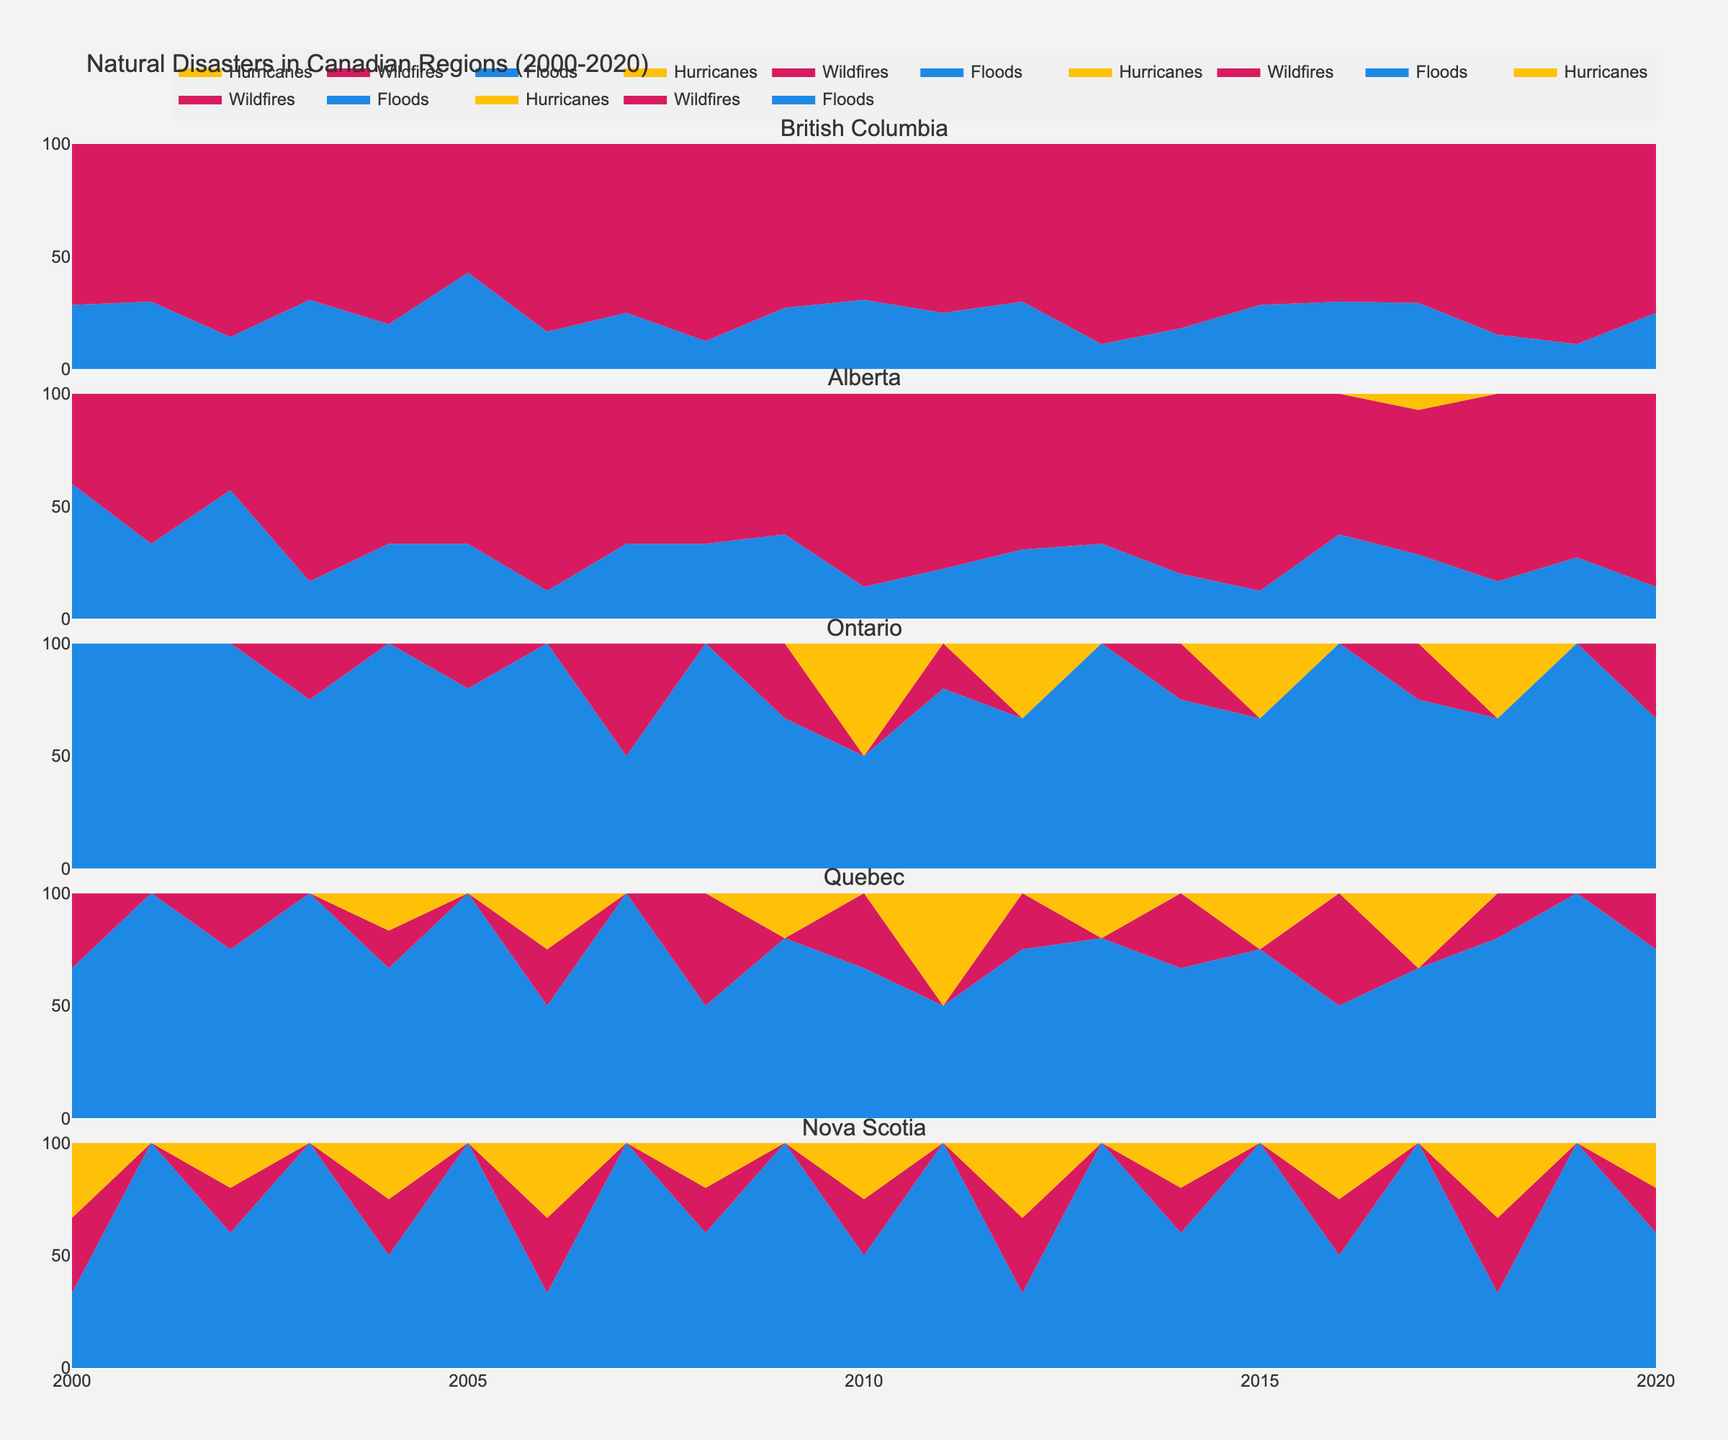What is the title of the plot? The title is usually displayed at the top of the plot, and it provides a summary of what the plot is about.
Answer: Natural Disasters in Canadian Regions (2000-2020) Which region has the highest number of wildfires around 2017? Look at the plot for the region where the wildfires count in 2017 reaches the highest point in the subplot dedicated to that region.
Answer: British Columbia Compare the number of floods between Alberta and Ontario in 2010. Which region had more floods? Check the specific subplots for Alberta and Ontario in the year 2010. Identify the heights of the flood-specific areas in each of these subplots.
Answer: Alberta From 2000 to 2020, how often did Quebec experience hurricanes? Look at the subplot for Quebec and count the years where any part of the area for hurricanes is non-zero. Check the plot around 0 occurrences where Quebec shows hurricanes.
Answer: 5 times What is the predominant disaster in Nova Scotia around 2010? For the year 2010 in the Nova Scotia subplot, compare the stacked areas' heights representing floods, wildfires, and hurricanes to see which disaster dominates.
Answer: Hurricanes Which region experienced hurricanes first and in which year? Scan through each subplot to identify the earliest year where the area representing hurricanes first appears.
Answer: Quebec, in 2004 What percentage of the disasters in Alberta were hurricanes in 2017? Look at the Alberta subplot for the year 2017, note the hurricane area and compare it with the total stacked area to estimate the percentage occupied by hurricanes.
Answer: Approximately 10% How did the frequency of wildfires in British Columbia change from 2005 to 2010? Observe the subplot for British Columbia and compare the heights of the area representing wildfires between the years 2005 and 2010.
Answer: It increased Is there a region where hurricanes were never observed from 2000 to 2020? If yes, which one? Check each subplot for the presence or absence of areas representing hurricanes. Identify the region(s) with no hurricane representation.
Answer: British Columbia 